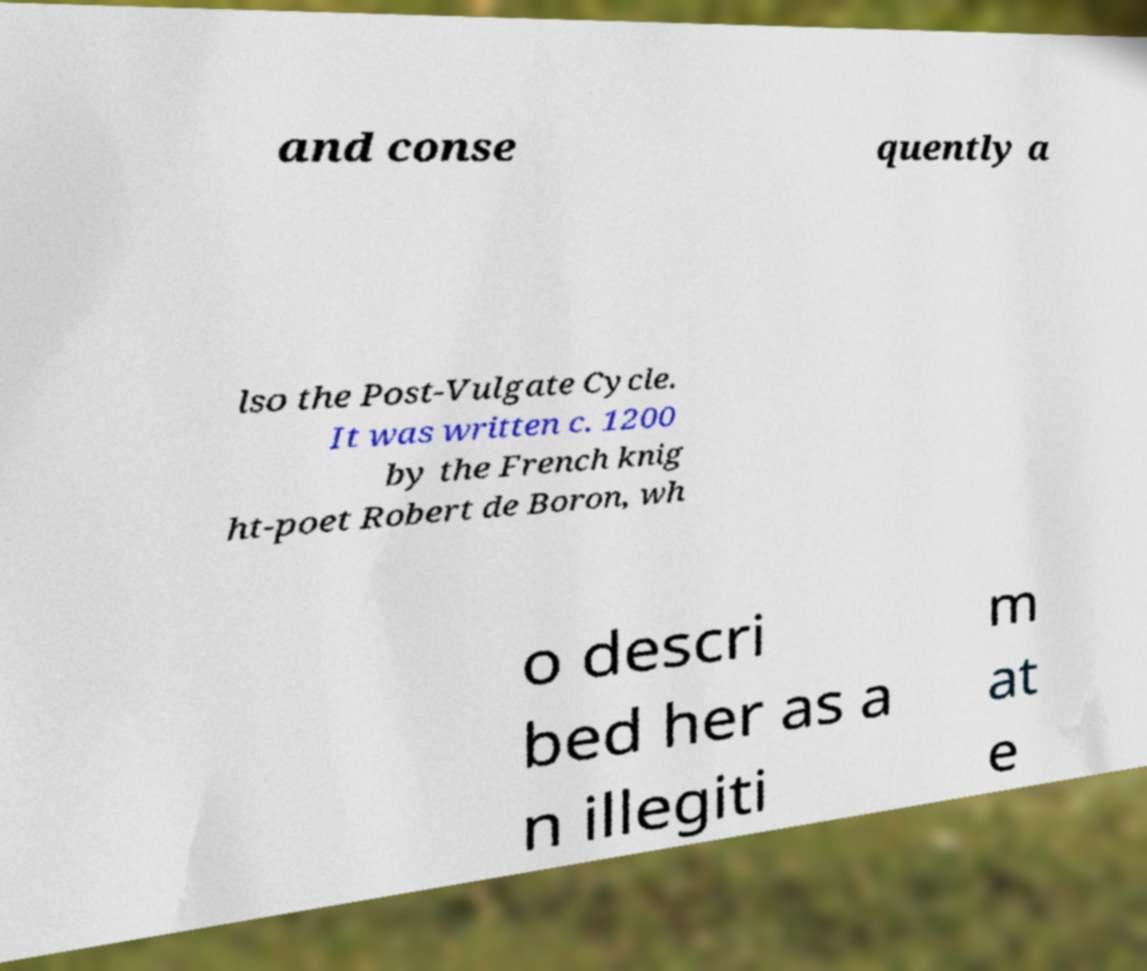What messages or text are displayed in this image? I need them in a readable, typed format. and conse quently a lso the Post-Vulgate Cycle. It was written c. 1200 by the French knig ht-poet Robert de Boron, wh o descri bed her as a n illegiti m at e 